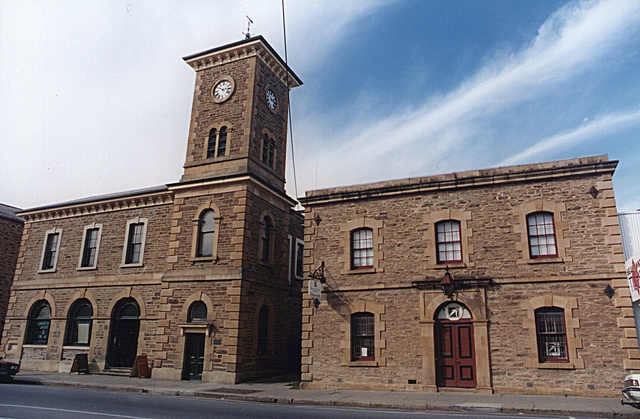Describe the objects in this image and their specific colors. I can see car in white, black, gray, lightgray, and darkgray tones, car in white, black, gray, and maroon tones, clock in white, lightgray, darkgray, gray, and black tones, and clock in white, black, and gray tones in this image. 